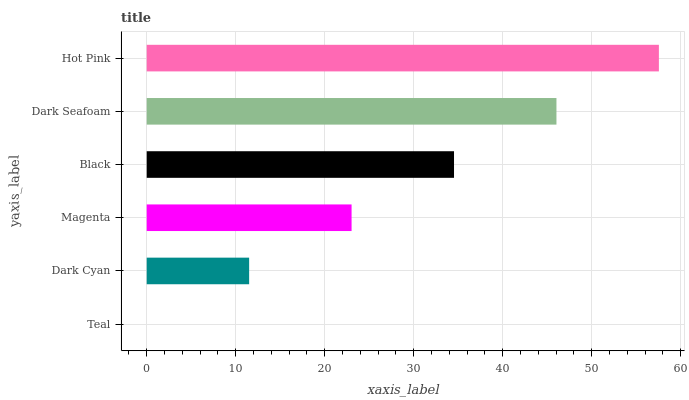Is Teal the minimum?
Answer yes or no. Yes. Is Hot Pink the maximum?
Answer yes or no. Yes. Is Dark Cyan the minimum?
Answer yes or no. No. Is Dark Cyan the maximum?
Answer yes or no. No. Is Dark Cyan greater than Teal?
Answer yes or no. Yes. Is Teal less than Dark Cyan?
Answer yes or no. Yes. Is Teal greater than Dark Cyan?
Answer yes or no. No. Is Dark Cyan less than Teal?
Answer yes or no. No. Is Black the high median?
Answer yes or no. Yes. Is Magenta the low median?
Answer yes or no. Yes. Is Dark Cyan the high median?
Answer yes or no. No. Is Hot Pink the low median?
Answer yes or no. No. 